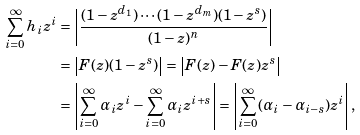Convert formula to latex. <formula><loc_0><loc_0><loc_500><loc_500>\sum _ { i = 0 } ^ { \infty } h _ { i } z ^ { i } & = \left | \frac { ( 1 - z ^ { d _ { 1 } } ) \cdots ( 1 - z ^ { d _ { m } } ) ( 1 - z ^ { s } ) } { ( 1 - z ) ^ { n } } \right | \\ & = \left | F ( z ) ( 1 - z ^ { s } ) \right | = \left | F ( z ) - F ( z ) z ^ { s } \right | \\ & = \left | \sum _ { i = 0 } ^ { \infty } \alpha _ { i } z ^ { i } - \sum _ { i = 0 } ^ { \infty } \alpha _ { i } z ^ { i + s } \right | = \left | \sum _ { i = 0 } ^ { \infty } ( \alpha _ { i } - \alpha _ { i - s } ) z ^ { i } \right | ,</formula> 